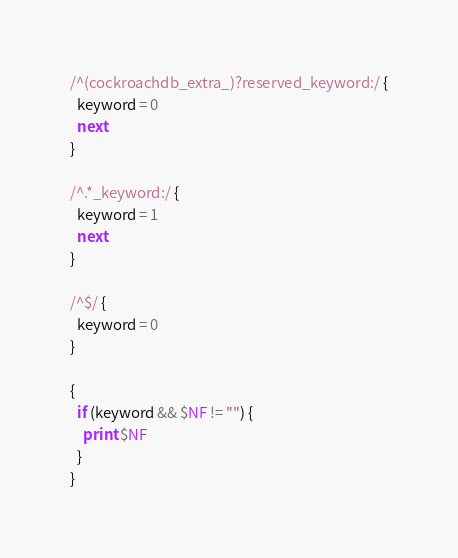<code> <loc_0><loc_0><loc_500><loc_500><_Awk_>/^(cockroachdb_extra_)?reserved_keyword:/ {
  keyword = 0
  next
}

/^.*_keyword:/ {
  keyword = 1
  next
}

/^$/ {
  keyword = 0
}

{
  if (keyword && $NF != "") {
    print $NF
  }
}
</code> 